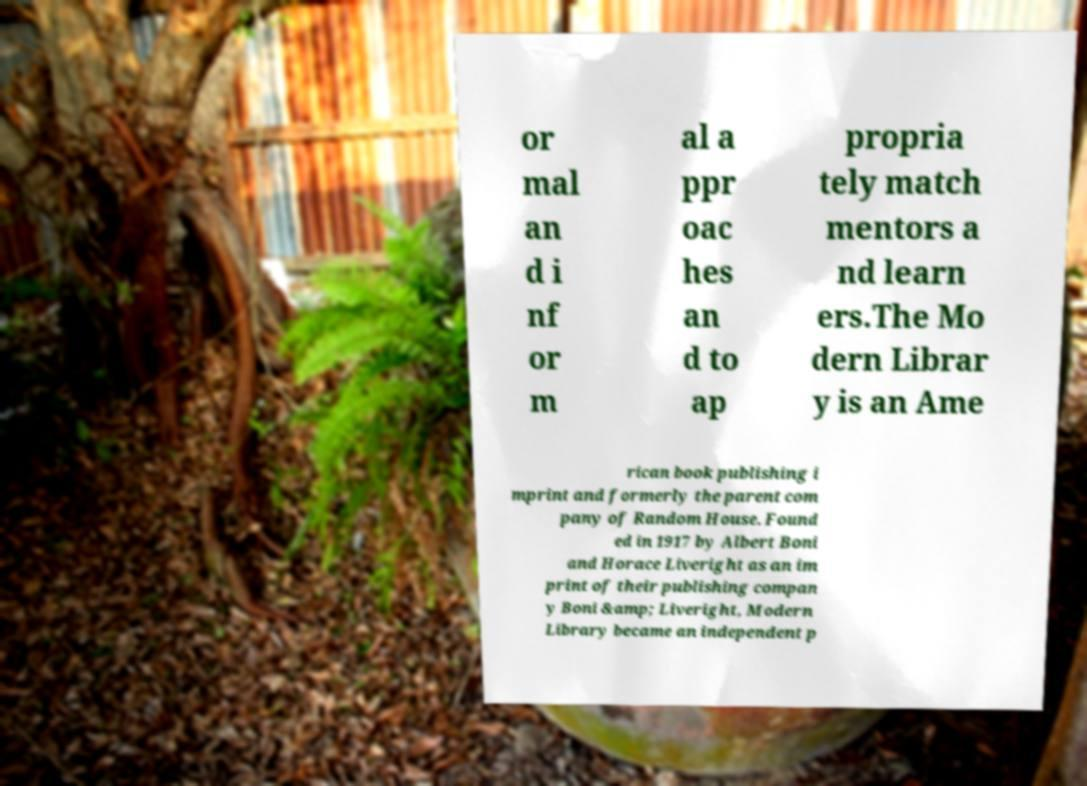Could you assist in decoding the text presented in this image and type it out clearly? or mal an d i nf or m al a ppr oac hes an d to ap propria tely match mentors a nd learn ers.The Mo dern Librar y is an Ame rican book publishing i mprint and formerly the parent com pany of Random House. Found ed in 1917 by Albert Boni and Horace Liveright as an im print of their publishing compan y Boni &amp; Liveright, Modern Library became an independent p 